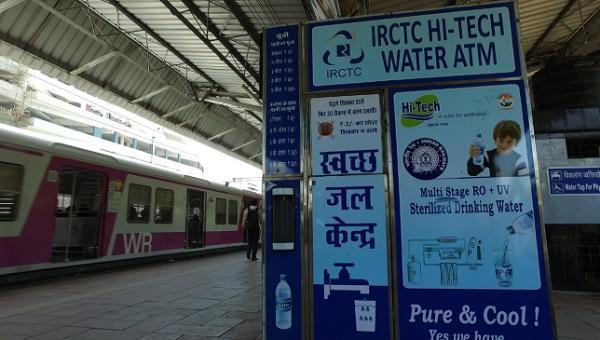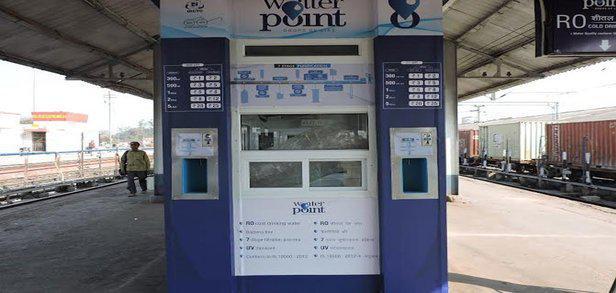The first image is the image on the left, the second image is the image on the right. Analyze the images presented: Is the assertion "In the left image, there are at least four different vending machines." valid? Answer yes or no. No. The first image is the image on the left, the second image is the image on the right. Considering the images on both sides, is "At least one of the images contains only a single vending machine." valid? Answer yes or no. Yes. 